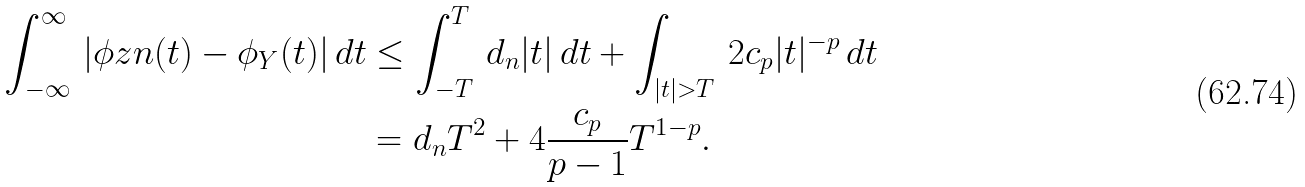Convert formula to latex. <formula><loc_0><loc_0><loc_500><loc_500>\int ^ { \infty } _ { - \infty } \, | \phi z n ( t ) - \phi _ { Y } ( t ) | \, d t & \leq \int ^ { T } _ { - T } \, d _ { n } | t | \, d t + \int _ { | t | > T } \, 2 c _ { p } | t | ^ { - p } \, d t \\ & = d _ { n } T ^ { 2 } + 4 \frac { c _ { p } } { p - 1 } T ^ { 1 - p } .</formula> 